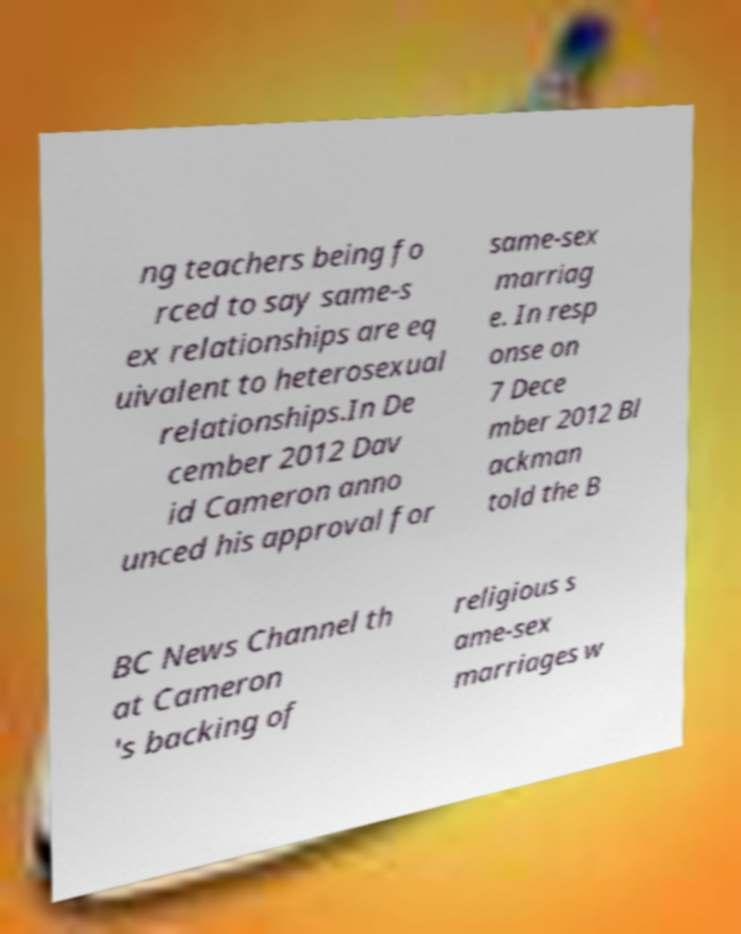Could you extract and type out the text from this image? ng teachers being fo rced to say same-s ex relationships are eq uivalent to heterosexual relationships.In De cember 2012 Dav id Cameron anno unced his approval for same-sex marriag e. In resp onse on 7 Dece mber 2012 Bl ackman told the B BC News Channel th at Cameron 's backing of religious s ame-sex marriages w 